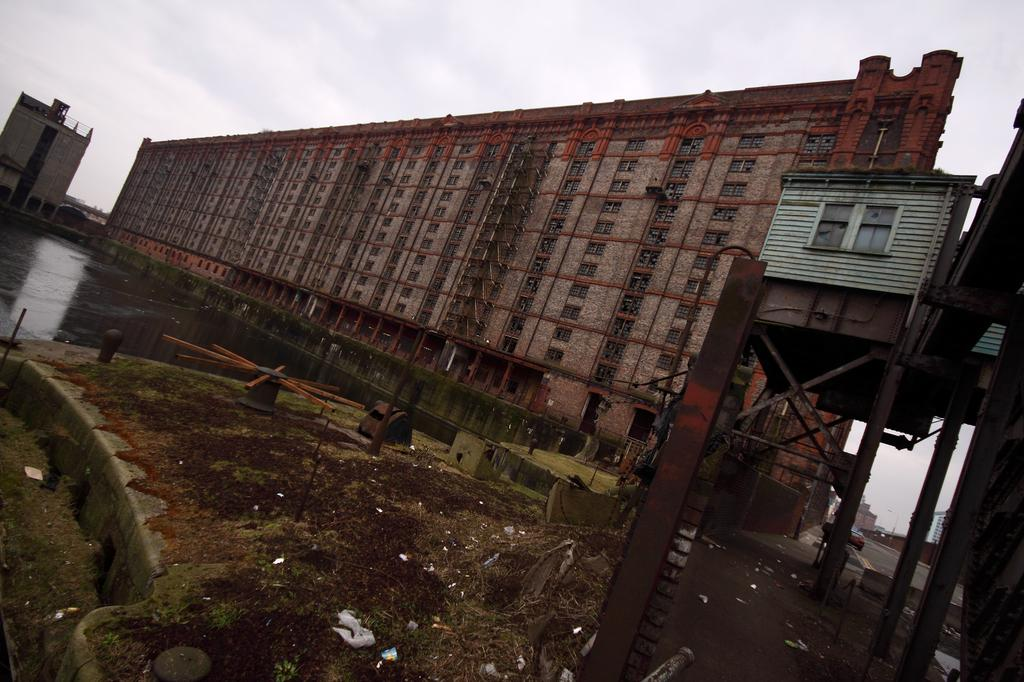What type of structures can be seen in the image? There are buildings in the image. What objects are present that might be used for construction or support? There are rods in the image. What type of objects are present that can move on the road? There are vehicles on the road in the image. What can be seen at the bottom of the image? There is water visible at the bottom of the image. What is visible at the top of the image? There is sky visible at the top of the image. Can you see a toothbrush being used to clean the buildings in the image? There is no toothbrush present in the image, and it is not being used to clean the buildings. What type of curve can be seen in the image? There is no curve present in the image; it features buildings, rods, wheels, vehicles, water, and sky. 